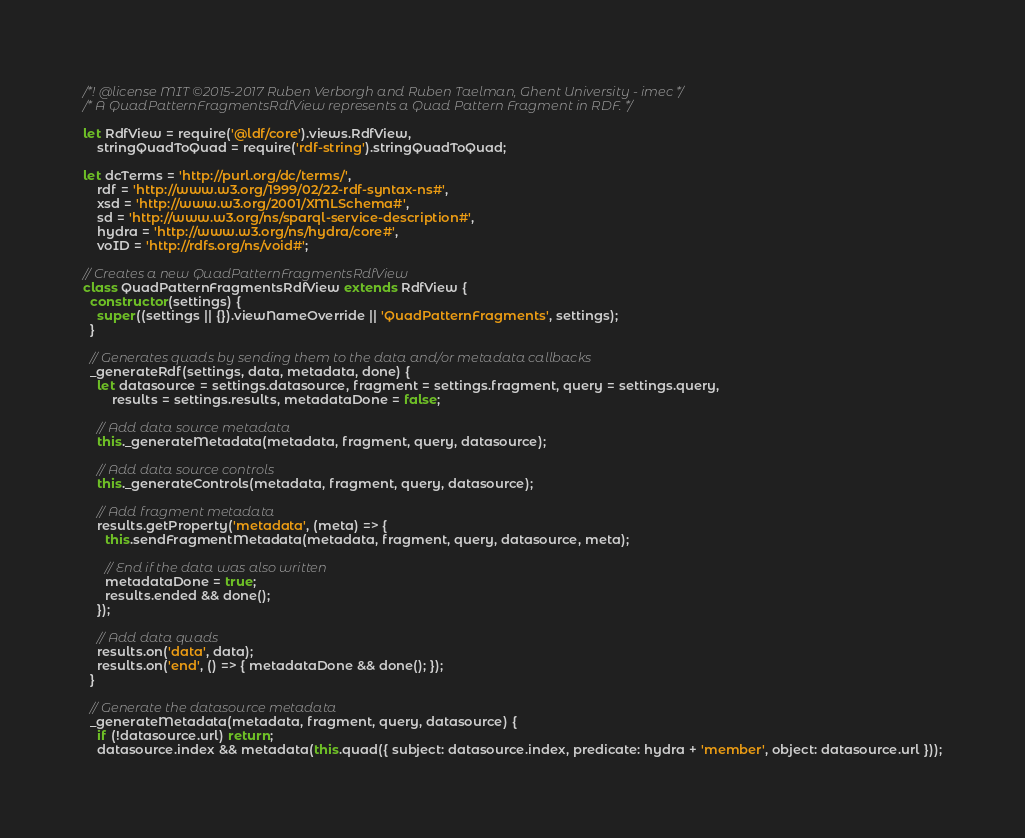<code> <loc_0><loc_0><loc_500><loc_500><_JavaScript_>/*! @license MIT ©2015-2017 Ruben Verborgh and Ruben Taelman, Ghent University - imec */
/* A QuadPatternFragmentsRdfView represents a Quad Pattern Fragment in RDF. */

let RdfView = require('@ldf/core').views.RdfView,
    stringQuadToQuad = require('rdf-string').stringQuadToQuad;

let dcTerms = 'http://purl.org/dc/terms/',
    rdf = 'http://www.w3.org/1999/02/22-rdf-syntax-ns#',
    xsd = 'http://www.w3.org/2001/XMLSchema#',
    sd = 'http://www.w3.org/ns/sparql-service-description#',
    hydra = 'http://www.w3.org/ns/hydra/core#',
    voID = 'http://rdfs.org/ns/void#';

// Creates a new QuadPatternFragmentsRdfView
class QuadPatternFragmentsRdfView extends RdfView {
  constructor(settings) {
    super((settings || {}).viewNameOverride || 'QuadPatternFragments', settings);
  }

  // Generates quads by sending them to the data and/or metadata callbacks
  _generateRdf(settings, data, metadata, done) {
    let datasource = settings.datasource, fragment = settings.fragment, query = settings.query,
        results = settings.results, metadataDone = false;

    // Add data source metadata
    this._generateMetadata(metadata, fragment, query, datasource);

    // Add data source controls
    this._generateControls(metadata, fragment, query, datasource);

    // Add fragment metadata
    results.getProperty('metadata', (meta) => {
      this.sendFragmentMetadata(metadata, fragment, query, datasource, meta);

      // End if the data was also written
      metadataDone = true;
      results.ended && done();
    });

    // Add data quads
    results.on('data', data);
    results.on('end', () => { metadataDone && done(); });
  }

  // Generate the datasource metadata
  _generateMetadata(metadata, fragment, query, datasource) {
    if (!datasource.url) return;
    datasource.index && metadata(this.quad({ subject: datasource.index, predicate: hydra + 'member', object: datasource.url }));</code> 